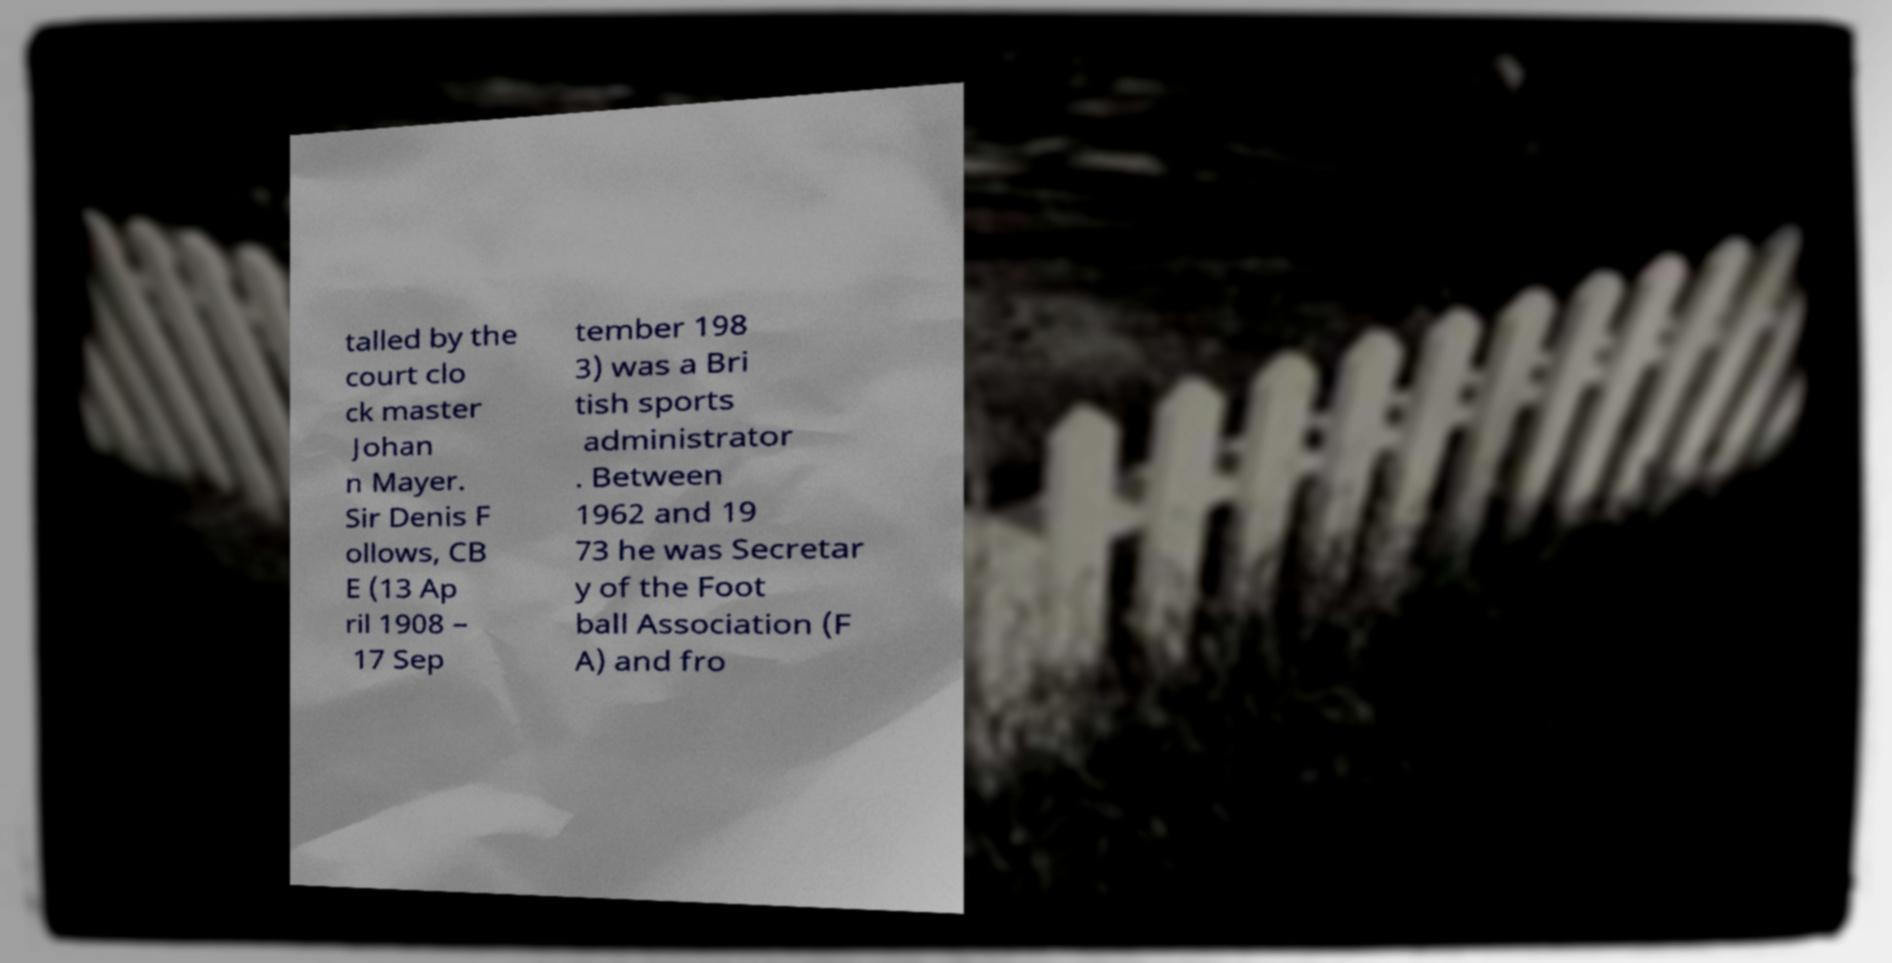For documentation purposes, I need the text within this image transcribed. Could you provide that? talled by the court clo ck master Johan n Mayer. Sir Denis F ollows, CB E (13 Ap ril 1908 – 17 Sep tember 198 3) was a Bri tish sports administrator . Between 1962 and 19 73 he was Secretar y of the Foot ball Association (F A) and fro 